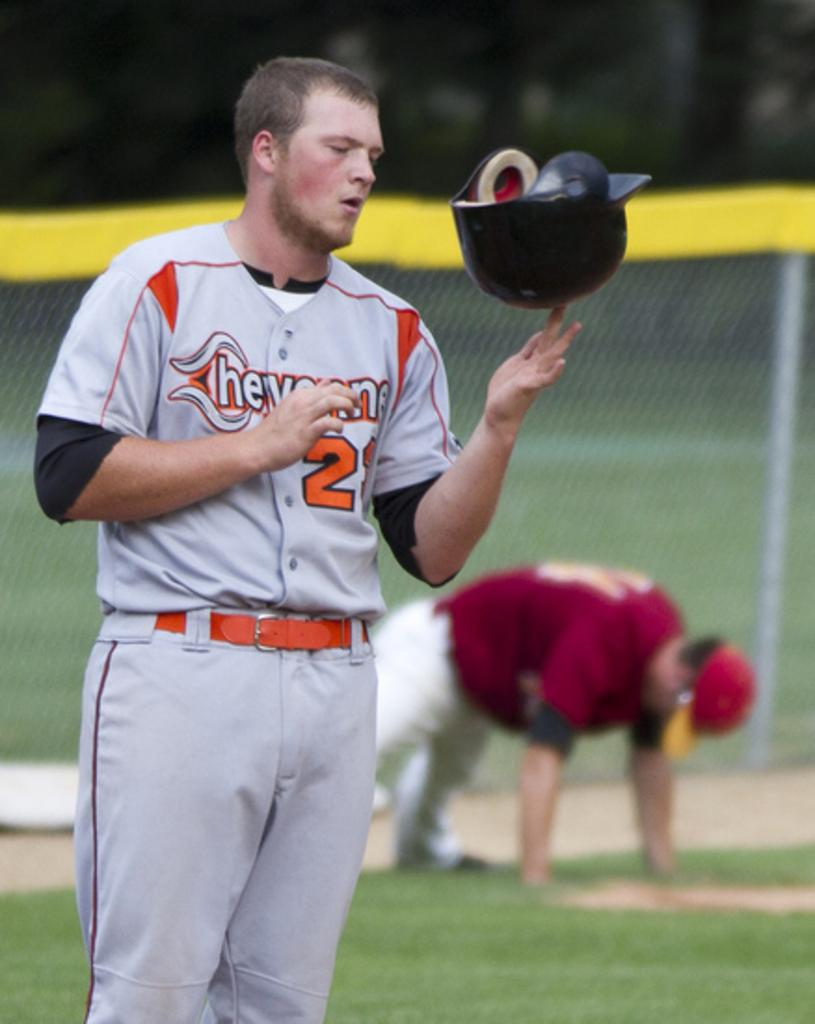<image>
Offer a succinct explanation of the picture presented. The baseball player from Cheyenne is balancing his batter's helmet. 